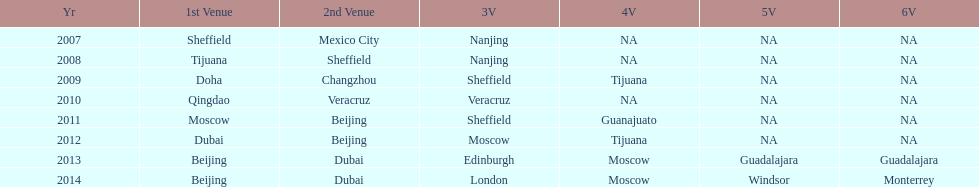Parse the full table. {'header': ['Yr', '1st Venue', '2nd Venue', '3V', '4V', '5V', '6V'], 'rows': [['2007', 'Sheffield', 'Mexico City', 'Nanjing', 'NA', 'NA', 'NA'], ['2008', 'Tijuana', 'Sheffield', 'Nanjing', 'NA', 'NA', 'NA'], ['2009', 'Doha', 'Changzhou', 'Sheffield', 'Tijuana', 'NA', 'NA'], ['2010', 'Qingdao', 'Veracruz', 'Veracruz', 'NA', 'NA', 'NA'], ['2011', 'Moscow', 'Beijing', 'Sheffield', 'Guanajuato', 'NA', 'NA'], ['2012', 'Dubai', 'Beijing', 'Moscow', 'Tijuana', 'NA', 'NA'], ['2013', 'Beijing', 'Dubai', 'Edinburgh', 'Moscow', 'Guadalajara', 'Guadalajara'], ['2014', 'Beijing', 'Dubai', 'London', 'Moscow', 'Windsor', 'Monterrey']]} Which two venue has no nations from 2007-2012 5th Venue, 6th Venue. 